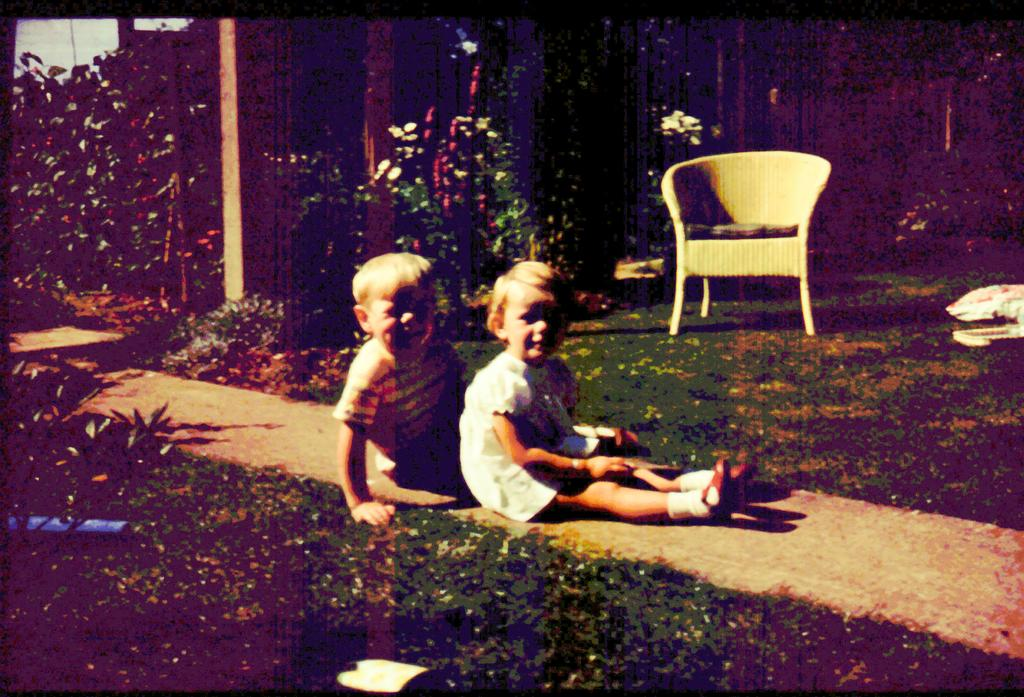How many children are in the image? There are two children in the image. What are the children doing in the image? The children are sitting on the ground. What can be seen in the background of the image? There are trees and a chair in the background of the image. Is there a foggy atmosphere in the image? There is no mention of fog in the image, so it cannot be determined from the provided facts. 